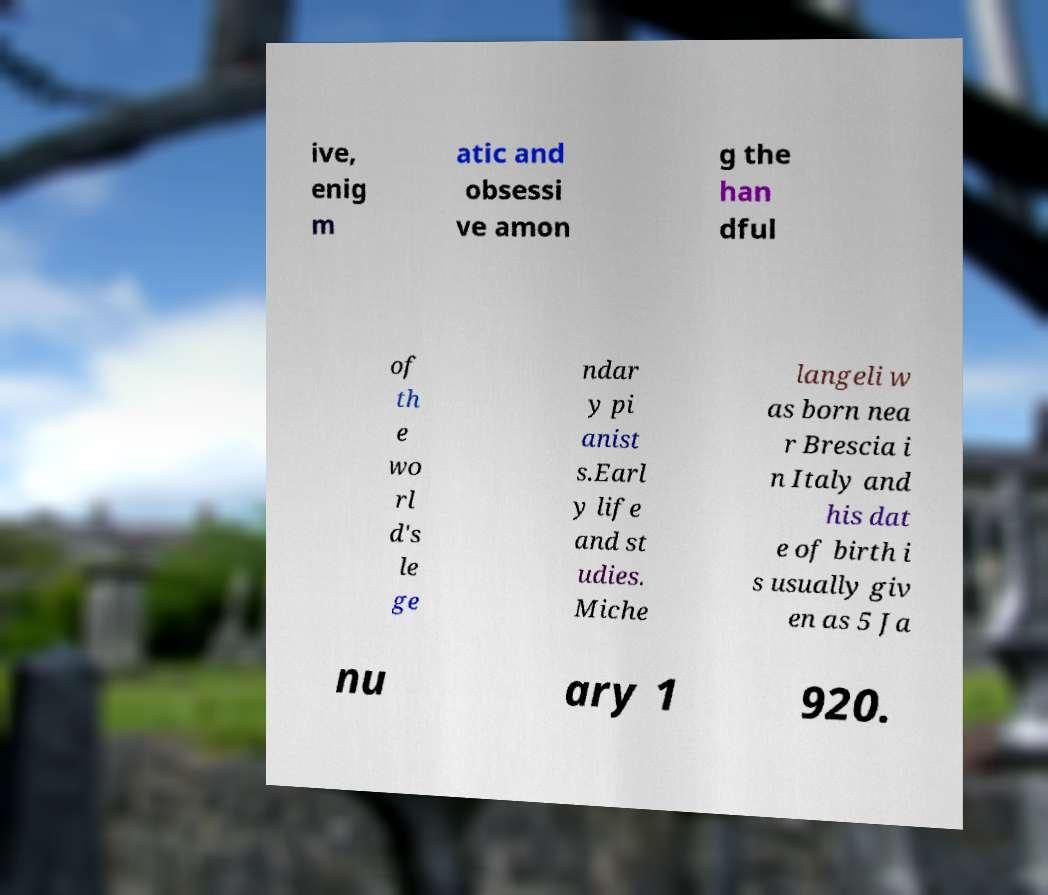What messages or text are displayed in this image? I need them in a readable, typed format. ive, enig m atic and obsessi ve amon g the han dful of th e wo rl d's le ge ndar y pi anist s.Earl y life and st udies. Miche langeli w as born nea r Brescia i n Italy and his dat e of birth i s usually giv en as 5 Ja nu ary 1 920. 